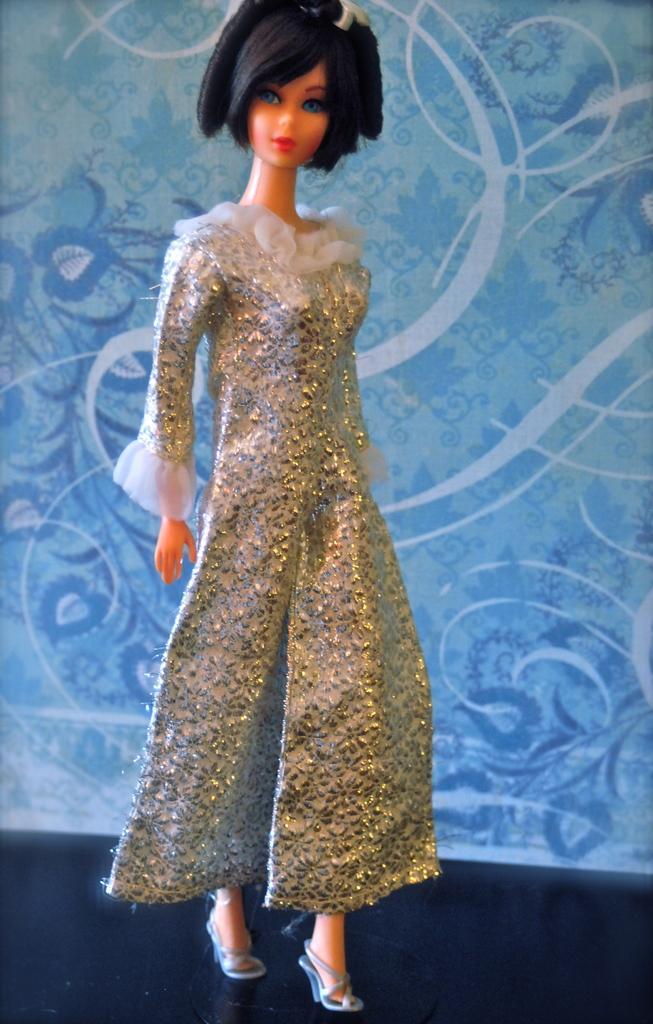In one or two sentences, can you explain what this image depicts? In this image I can see a barbie doll. On the doll I can see some clothes. In the background I can see a blue color wall which has some design on it. 